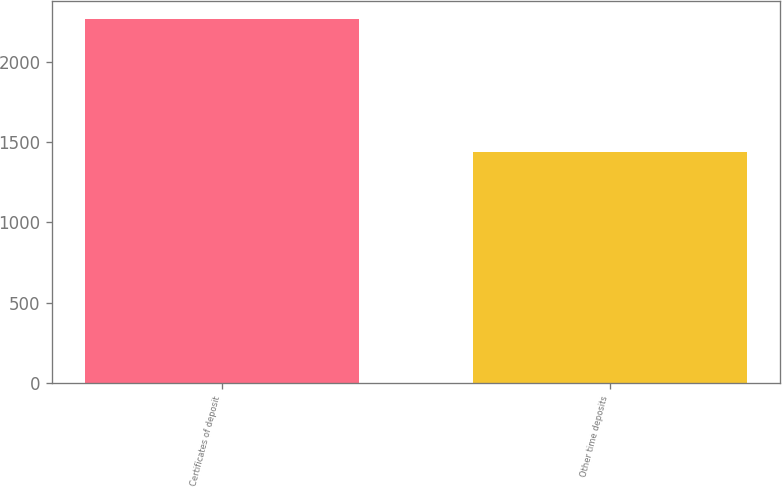Convert chart to OTSL. <chart><loc_0><loc_0><loc_500><loc_500><bar_chart><fcel>Certificates of deposit<fcel>Other time deposits<nl><fcel>2266<fcel>1438<nl></chart> 